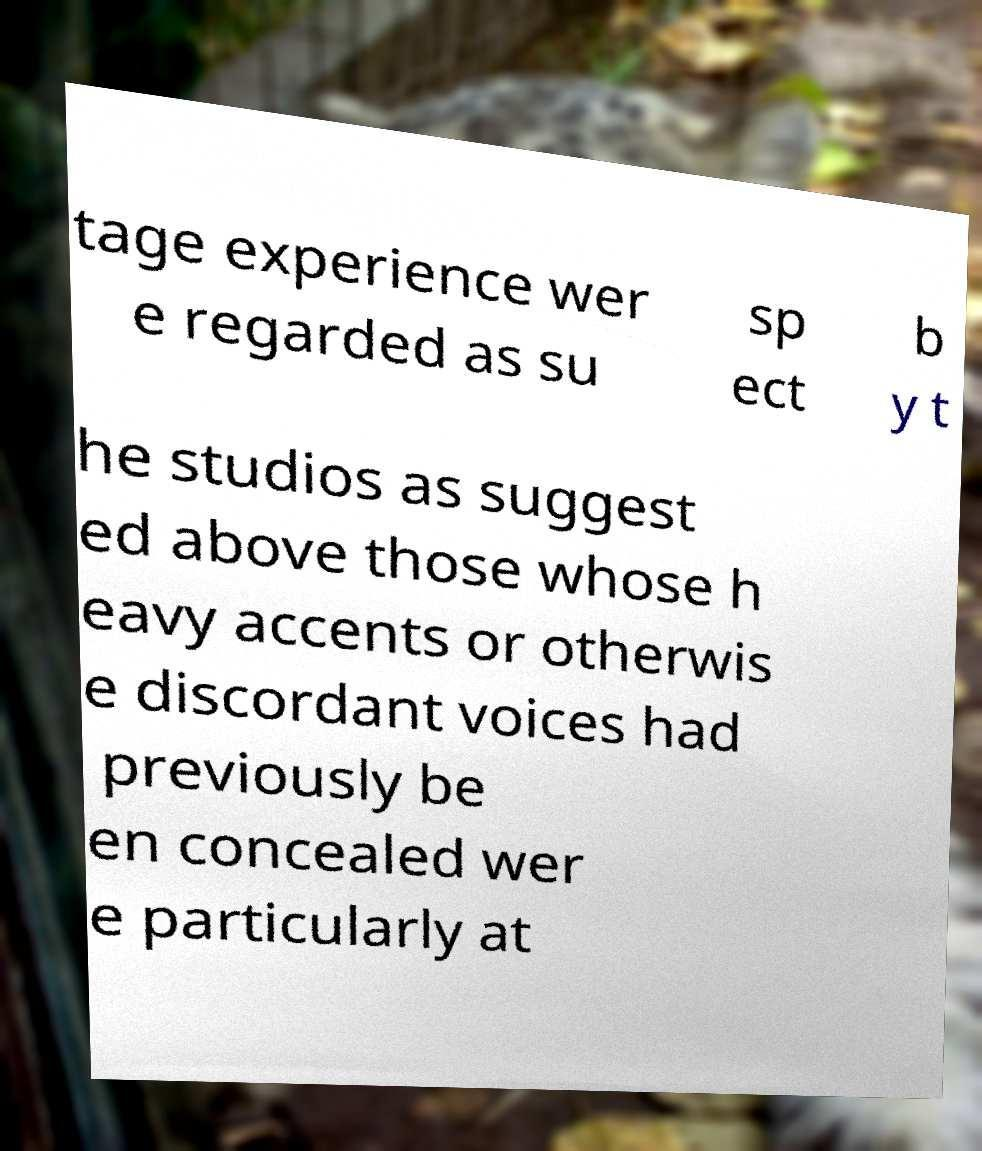Please read and relay the text visible in this image. What does it say? tage experience wer e regarded as su sp ect b y t he studios as suggest ed above those whose h eavy accents or otherwis e discordant voices had previously be en concealed wer e particularly at 